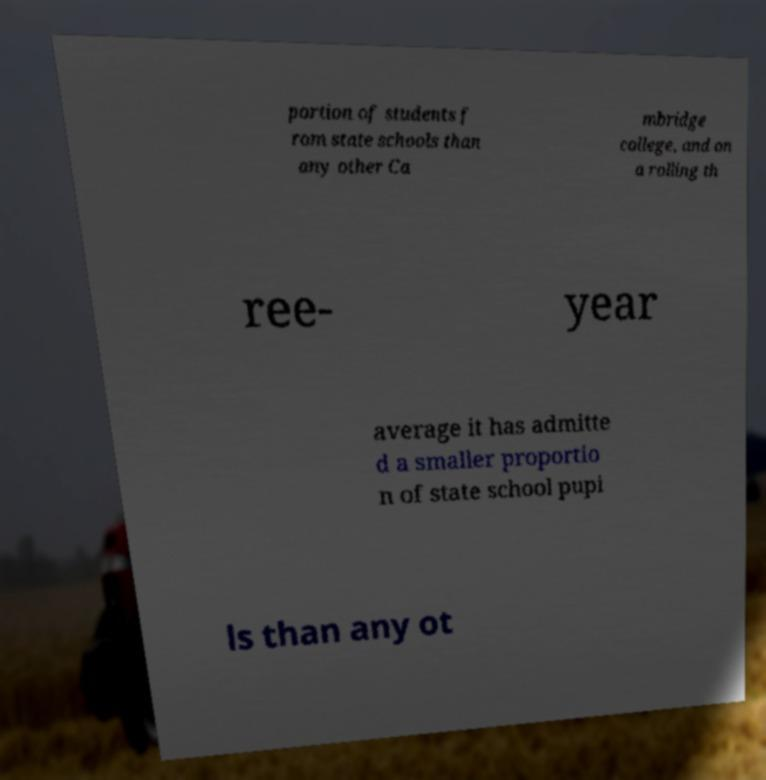There's text embedded in this image that I need extracted. Can you transcribe it verbatim? portion of students f rom state schools than any other Ca mbridge college, and on a rolling th ree- year average it has admitte d a smaller proportio n of state school pupi ls than any ot 